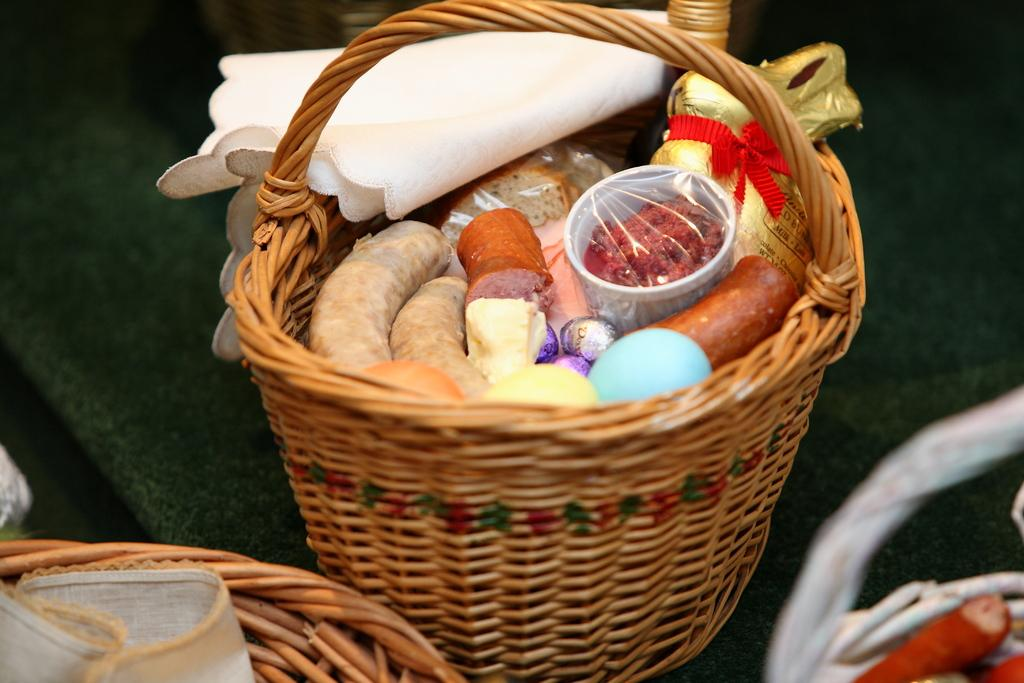What objects are present in the image? There are baskets in the image. What can be found inside the baskets? There are eatables and tissues in the baskets. Are there any additional items in the baskets? Yes, there are covers in the baskets. What type of string is used to tie the baskets in the image? There is no mention of string or any ties in the image; the baskets are not described as being tied or secured. Can you see any scissors in the image? There is no mention of scissors in the image; they are not present or visible. 